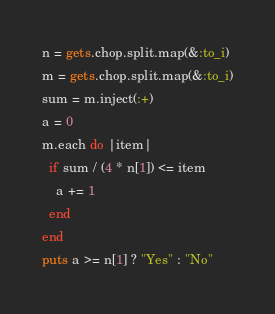Convert code to text. <code><loc_0><loc_0><loc_500><loc_500><_Ruby_>n = gets.chop.split.map(&:to_i)
m = gets.chop.split.map(&:to_i)
sum = m.inject(:+)
a = 0
m.each do |item|
  if sum / (4 * n[1]) <= item
    a += 1
  end
end
puts a >= n[1] ? "Yes" : "No"
</code> 